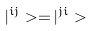Convert formula to latex. <formula><loc_0><loc_0><loc_500><loc_500>| ^ { i j } > = | ^ { j i } ></formula> 